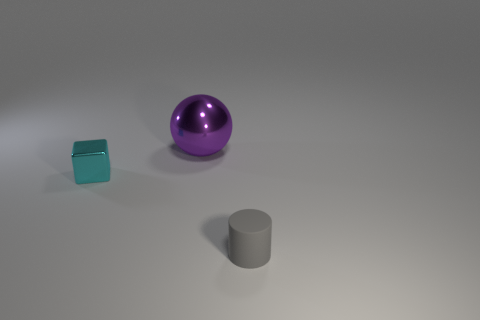Are there more tiny cyan blocks to the right of the big purple ball than cyan shiny things?
Provide a short and direct response. No. There is a metallic object that is behind the cyan object; is it the same shape as the small cyan metallic object?
Give a very brief answer. No. How many purple things are large metal things or matte things?
Your answer should be compact. 1. Is the number of small cyan objects greater than the number of large matte things?
Provide a succinct answer. Yes. The metallic object that is the same size as the cylinder is what color?
Ensure brevity in your answer.  Cyan. How many cylinders are cyan things or small gray rubber things?
Provide a succinct answer. 1. Is the shape of the tiny gray rubber thing the same as the small thing that is to the left of the small gray cylinder?
Your response must be concise. No. What number of purple things are the same size as the cyan metal thing?
Offer a terse response. 0. Is the shape of the tiny object that is behind the tiny gray matte cylinder the same as the small object on the right side of the large purple thing?
Keep it short and to the point. No. What color is the small thing in front of the small thing on the left side of the purple shiny object?
Provide a succinct answer. Gray. 